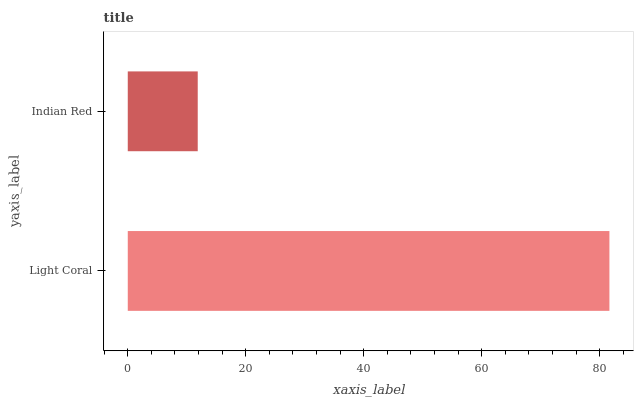Is Indian Red the minimum?
Answer yes or no. Yes. Is Light Coral the maximum?
Answer yes or no. Yes. Is Indian Red the maximum?
Answer yes or no. No. Is Light Coral greater than Indian Red?
Answer yes or no. Yes. Is Indian Red less than Light Coral?
Answer yes or no. Yes. Is Indian Red greater than Light Coral?
Answer yes or no. No. Is Light Coral less than Indian Red?
Answer yes or no. No. Is Light Coral the high median?
Answer yes or no. Yes. Is Indian Red the low median?
Answer yes or no. Yes. Is Indian Red the high median?
Answer yes or no. No. Is Light Coral the low median?
Answer yes or no. No. 